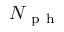<formula> <loc_0><loc_0><loc_500><loc_500>N _ { p h }</formula> 